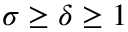<formula> <loc_0><loc_0><loc_500><loc_500>\sigma \geq \delta \geq 1</formula> 